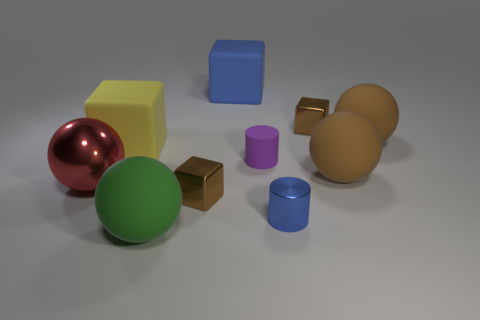Subtract all spheres. How many objects are left? 6 Subtract 0 green cubes. How many objects are left? 10 Subtract all blue rubber things. Subtract all big green metal cylinders. How many objects are left? 9 Add 1 tiny shiny things. How many tiny shiny things are left? 4 Add 3 small blue shiny cylinders. How many small blue shiny cylinders exist? 4 